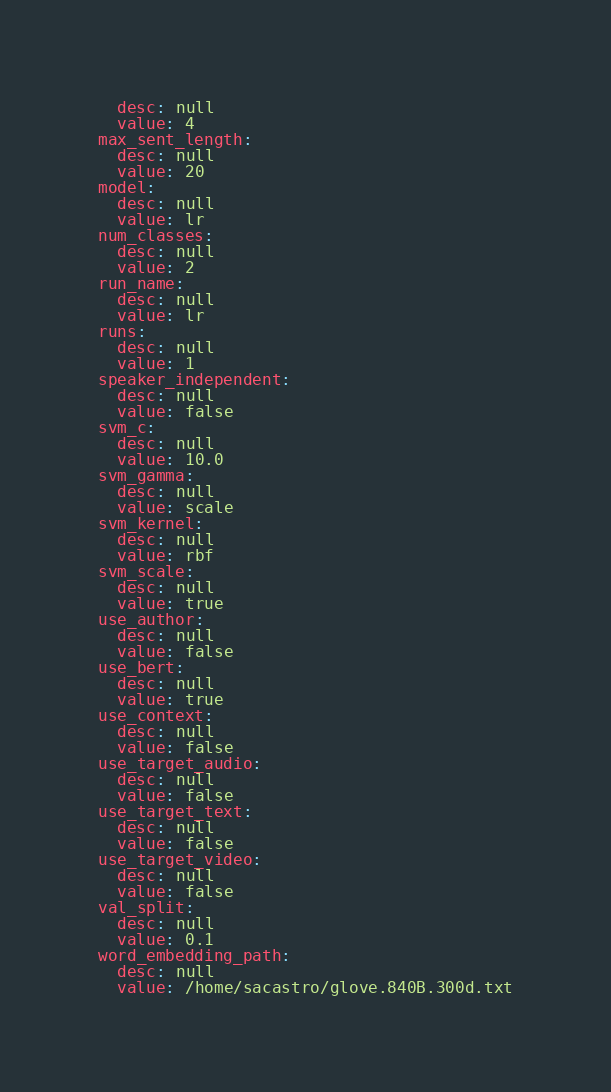Convert code to text. <code><loc_0><loc_0><loc_500><loc_500><_YAML_>  desc: null
  value: 4
max_sent_length:
  desc: null
  value: 20
model:
  desc: null
  value: lr
num_classes:
  desc: null
  value: 2
run_name:
  desc: null
  value: lr
runs:
  desc: null
  value: 1
speaker_independent:
  desc: null
  value: false
svm_c:
  desc: null
  value: 10.0
svm_gamma:
  desc: null
  value: scale
svm_kernel:
  desc: null
  value: rbf
svm_scale:
  desc: null
  value: true
use_author:
  desc: null
  value: false
use_bert:
  desc: null
  value: true
use_context:
  desc: null
  value: false
use_target_audio:
  desc: null
  value: false
use_target_text:
  desc: null
  value: false
use_target_video:
  desc: null
  value: false
val_split:
  desc: null
  value: 0.1
word_embedding_path:
  desc: null
  value: /home/sacastro/glove.840B.300d.txt
</code> 